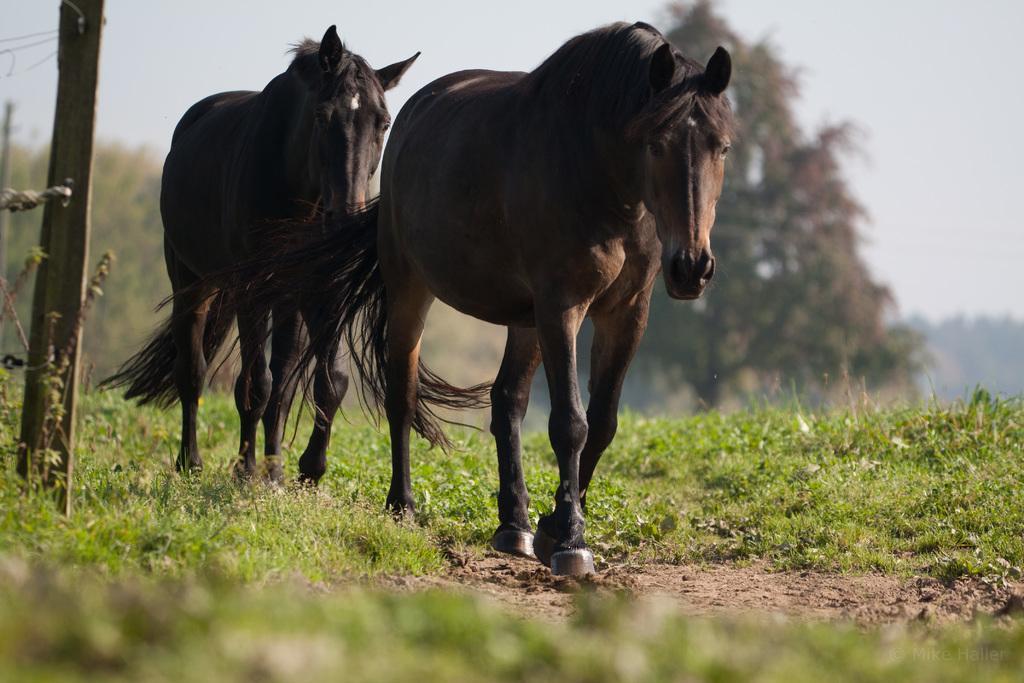Can you describe this image briefly? In this image there are two horses on the grass surface, on the left of the horses there is a pole with barbed wire fence, behind the horses there are trees. 